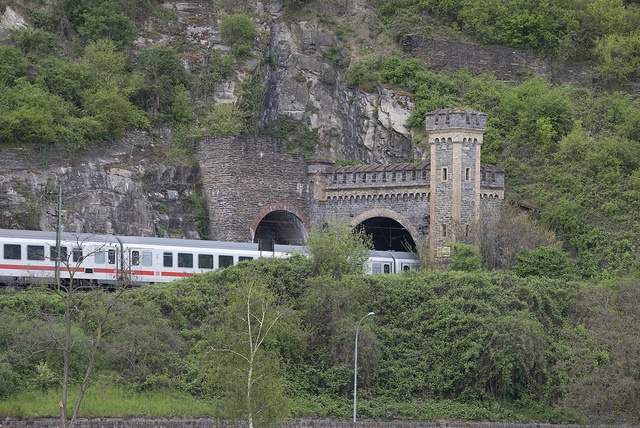Describe the objects in this image and their specific colors. I can see a train in gray, lavender, and darkgray tones in this image. 